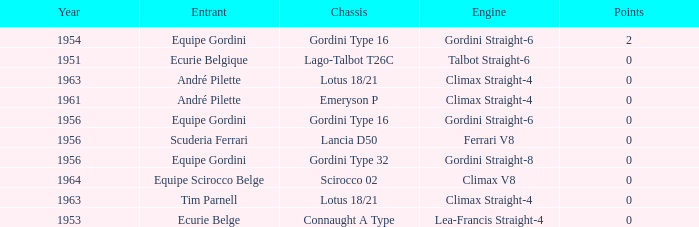Who used Gordini Straight-6 in 1956? Equipe Gordini. 